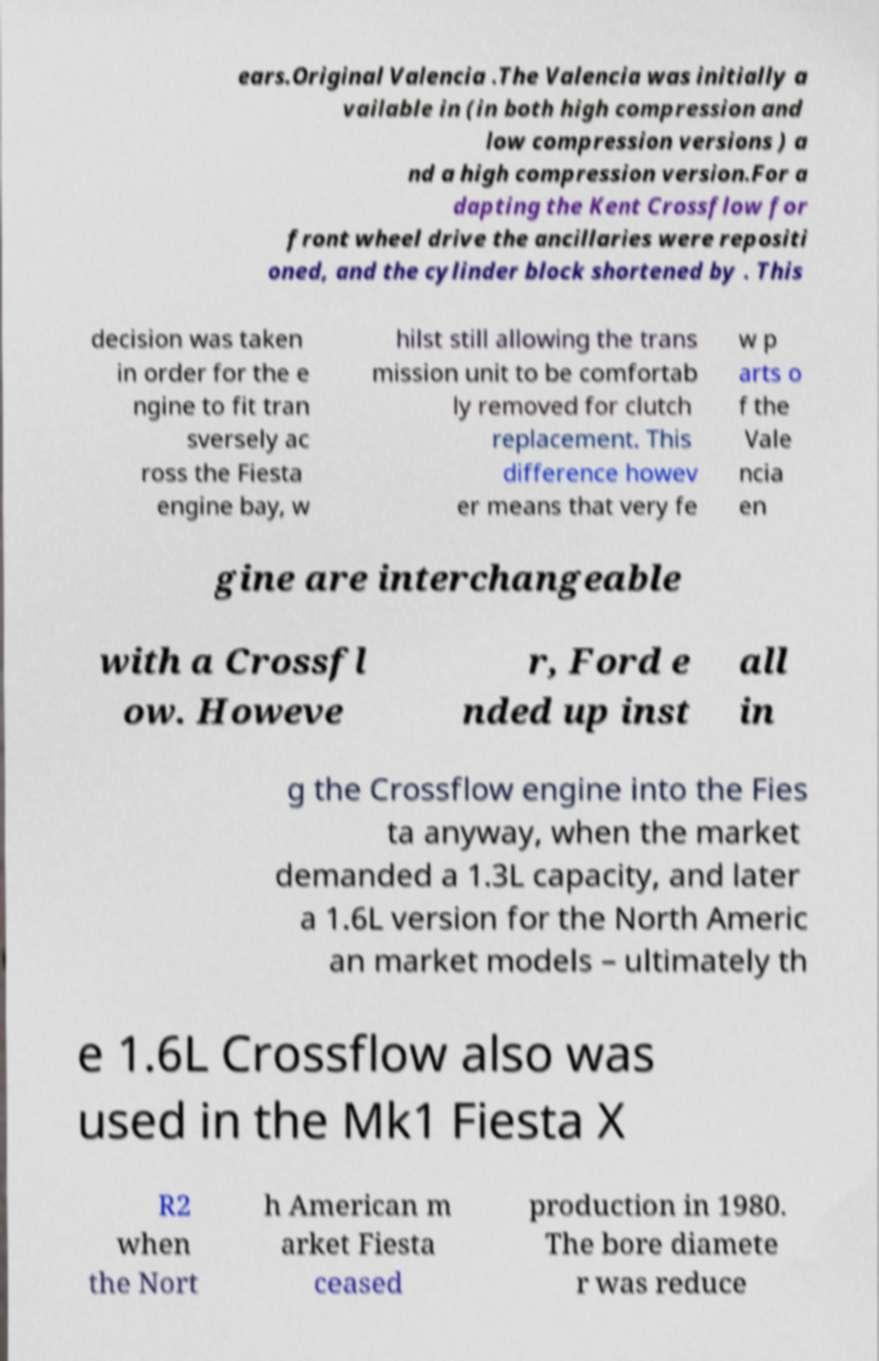Can you read and provide the text displayed in the image?This photo seems to have some interesting text. Can you extract and type it out for me? ears.Original Valencia .The Valencia was initially a vailable in (in both high compression and low compression versions ) a nd a high compression version.For a dapting the Kent Crossflow for front wheel drive the ancillaries were repositi oned, and the cylinder block shortened by . This decision was taken in order for the e ngine to fit tran sversely ac ross the Fiesta engine bay, w hilst still allowing the trans mission unit to be comfortab ly removed for clutch replacement. This difference howev er means that very fe w p arts o f the Vale ncia en gine are interchangeable with a Crossfl ow. Howeve r, Ford e nded up inst all in g the Crossflow engine into the Fies ta anyway, when the market demanded a 1.3L capacity, and later a 1.6L version for the North Americ an market models – ultimately th e 1.6L Crossflow also was used in the Mk1 Fiesta X R2 when the Nort h American m arket Fiesta ceased production in 1980. The bore diamete r was reduce 